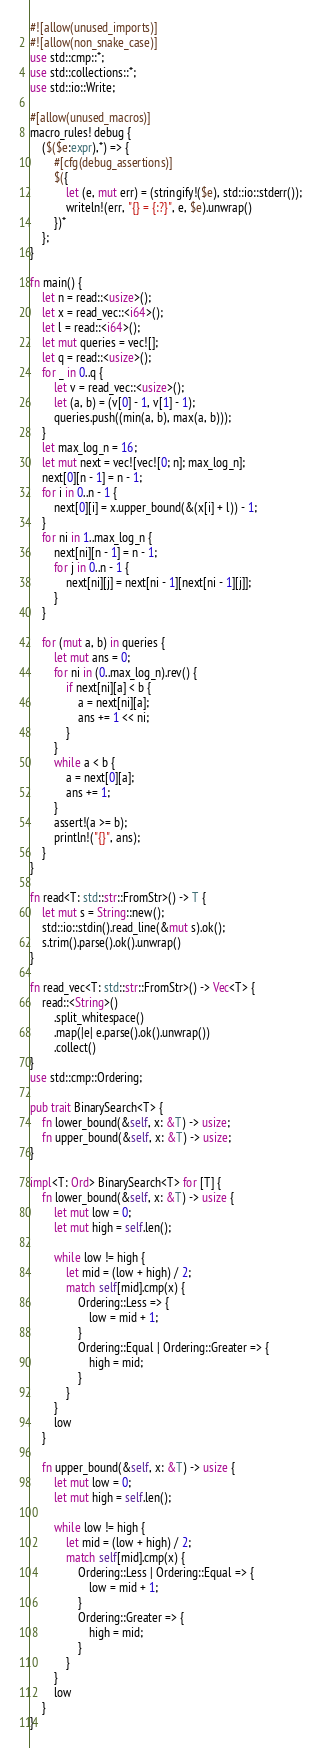Convert code to text. <code><loc_0><loc_0><loc_500><loc_500><_Rust_>#![allow(unused_imports)]
#![allow(non_snake_case)]
use std::cmp::*;
use std::collections::*;
use std::io::Write;

#[allow(unused_macros)]
macro_rules! debug {
    ($($e:expr),*) => {
        #[cfg(debug_assertions)]
        $({
            let (e, mut err) = (stringify!($e), std::io::stderr());
            writeln!(err, "{} = {:?}", e, $e).unwrap()
        })*
    };
}

fn main() {
    let n = read::<usize>();
    let x = read_vec::<i64>();
    let l = read::<i64>();
    let mut queries = vec![];
    let q = read::<usize>();
    for _ in 0..q {
        let v = read_vec::<usize>();
        let (a, b) = (v[0] - 1, v[1] - 1);
        queries.push((min(a, b), max(a, b)));
    }
    let max_log_n = 16;
    let mut next = vec![vec![0; n]; max_log_n];
    next[0][n - 1] = n - 1;
    for i in 0..n - 1 {
        next[0][i] = x.upper_bound(&(x[i] + l)) - 1;
    }
    for ni in 1..max_log_n {
        next[ni][n - 1] = n - 1;
        for j in 0..n - 1 {
            next[ni][j] = next[ni - 1][next[ni - 1][j]];
        }
    }

    for (mut a, b) in queries {
        let mut ans = 0;
        for ni in (0..max_log_n).rev() {
            if next[ni][a] < b {
                a = next[ni][a];
                ans += 1 << ni;
            }
        }
        while a < b {
            a = next[0][a];
            ans += 1;
        }
        assert!(a >= b);
        println!("{}", ans);
    }
}

fn read<T: std::str::FromStr>() -> T {
    let mut s = String::new();
    std::io::stdin().read_line(&mut s).ok();
    s.trim().parse().ok().unwrap()
}

fn read_vec<T: std::str::FromStr>() -> Vec<T> {
    read::<String>()
        .split_whitespace()
        .map(|e| e.parse().ok().unwrap())
        .collect()
}
use std::cmp::Ordering;

pub trait BinarySearch<T> {
    fn lower_bound(&self, x: &T) -> usize;
    fn upper_bound(&self, x: &T) -> usize;
}

impl<T: Ord> BinarySearch<T> for [T] {
    fn lower_bound(&self, x: &T) -> usize {
        let mut low = 0;
        let mut high = self.len();

        while low != high {
            let mid = (low + high) / 2;
            match self[mid].cmp(x) {
                Ordering::Less => {
                    low = mid + 1;
                }
                Ordering::Equal | Ordering::Greater => {
                    high = mid;
                }
            }
        }
        low
    }

    fn upper_bound(&self, x: &T) -> usize {
        let mut low = 0;
        let mut high = self.len();

        while low != high {
            let mid = (low + high) / 2;
            match self[mid].cmp(x) {
                Ordering::Less | Ordering::Equal => {
                    low = mid + 1;
                }
                Ordering::Greater => {
                    high = mid;
                }
            }
        }
        low
    }
}
</code> 